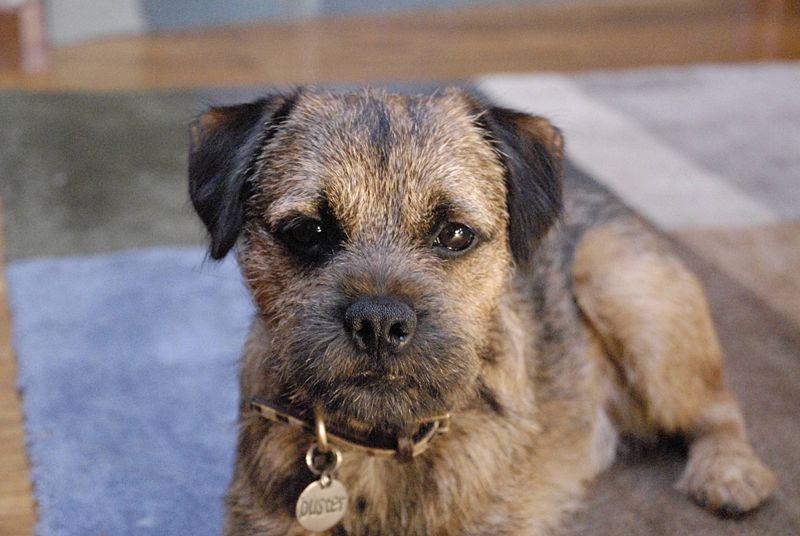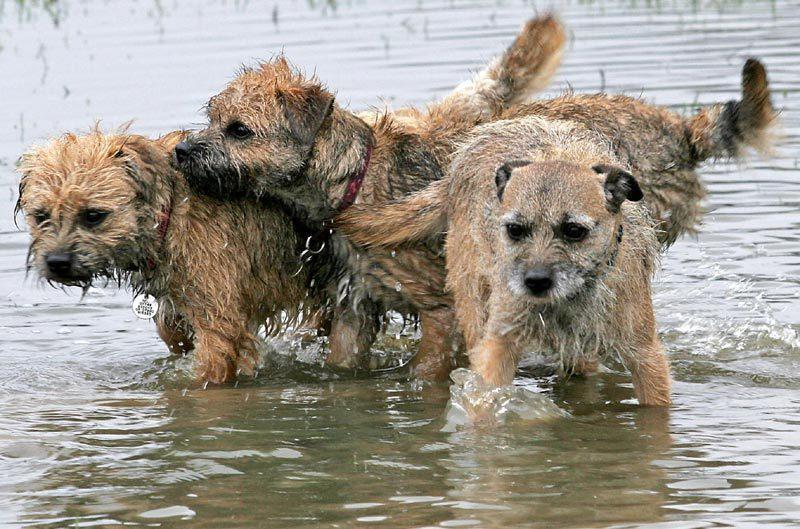The first image is the image on the left, the second image is the image on the right. Examine the images to the left and right. Is the description "There are no more than four dogs" accurate? Answer yes or no. Yes. 